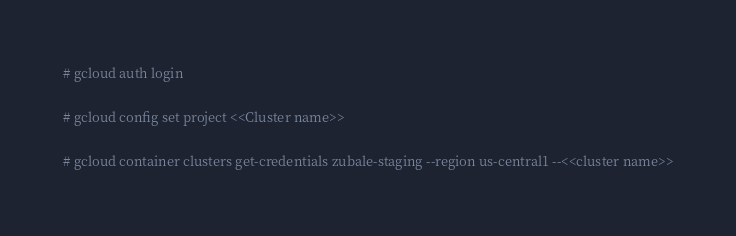Convert code to text. <code><loc_0><loc_0><loc_500><loc_500><_Bash_># gcloud auth login

# gcloud config set project <<Cluster name>>

# gcloud container clusters get-credentials zubale-staging --region us-central1 --<<cluster name>>

</code> 